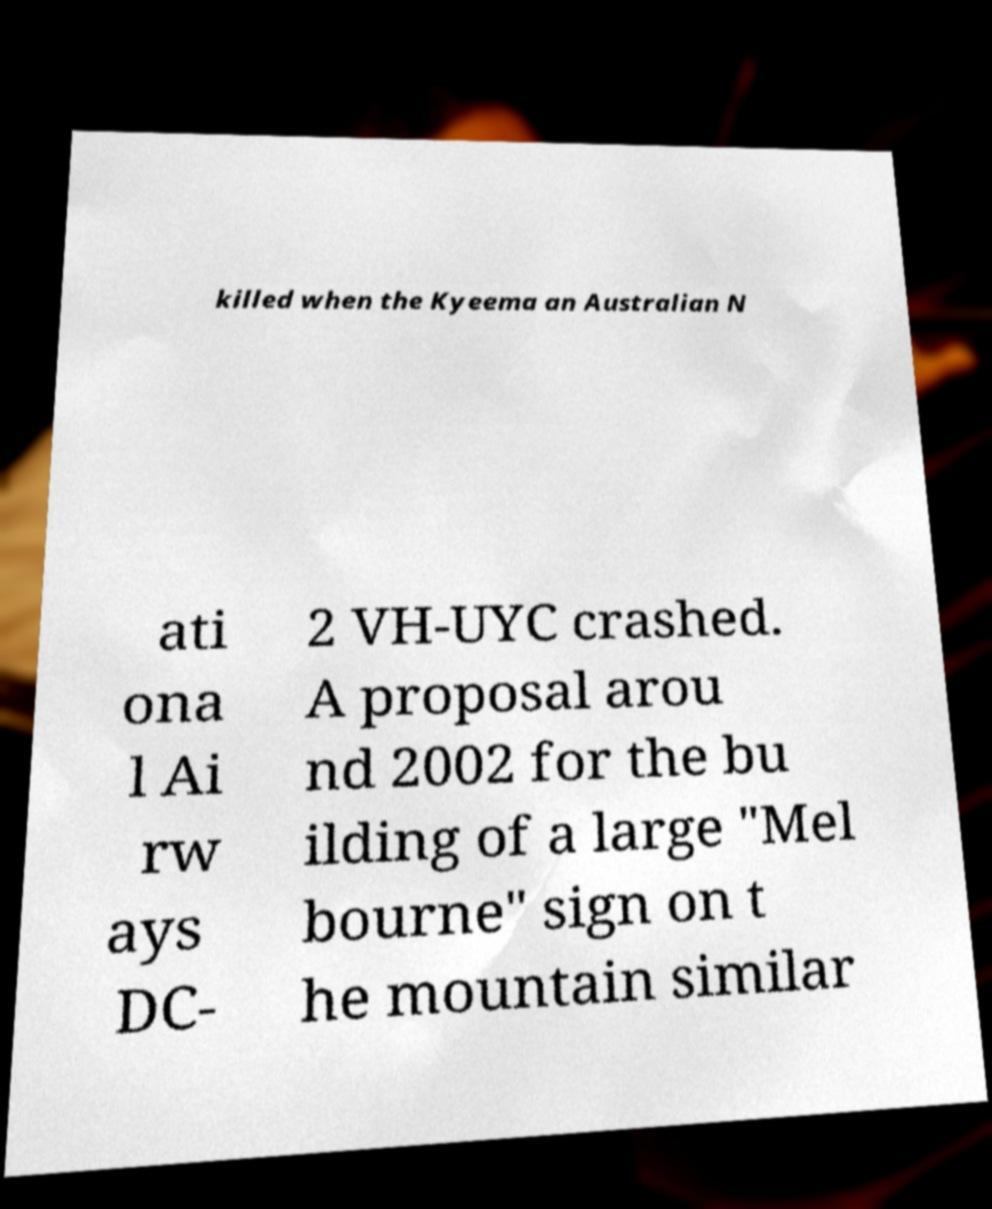Could you assist in decoding the text presented in this image and type it out clearly? killed when the Kyeema an Australian N ati ona l Ai rw ays DC- 2 VH-UYC crashed. A proposal arou nd 2002 for the bu ilding of a large "Mel bourne" sign on t he mountain similar 